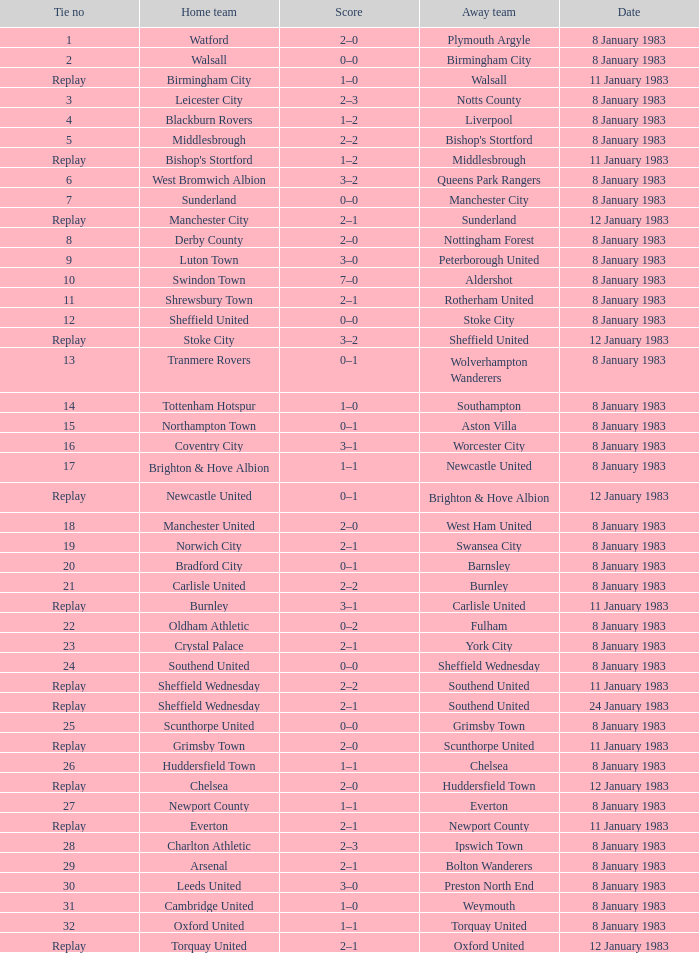In the game with leeds united as the home team, what was the ultimate score? 3–0. 